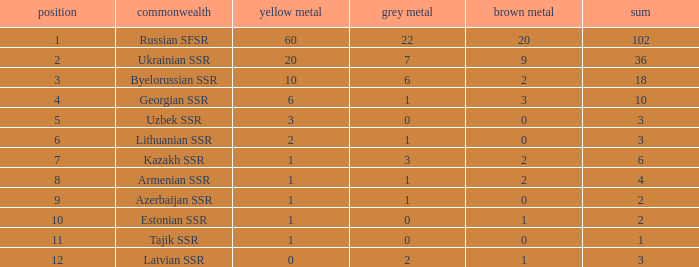What is the sum of bronzes for teams with more than 2 gold, ranked under 3, and less than 22 silver? 9.0. 